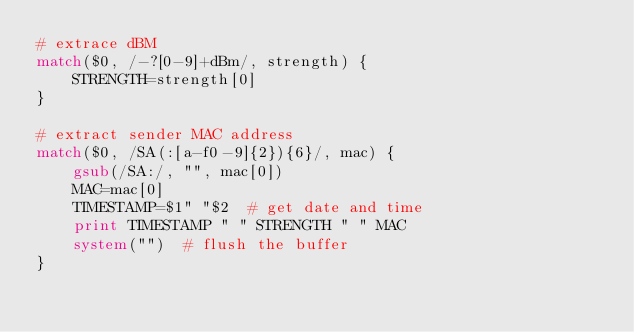<code> <loc_0><loc_0><loc_500><loc_500><_Awk_># extrace dBM
match($0, /-?[0-9]+dBm/, strength) {
	STRENGTH=strength[0]
}

# extract sender MAC address
match($0, /SA(:[a-f0-9]{2}){6}/, mac) {
	gsub(/SA:/, "", mac[0])
	MAC=mac[0]
	TIMESTAMP=$1" "$2  # get date and time
	print TIMESTAMP " " STRENGTH " " MAC
	system("")  # flush the buffer
}
</code> 